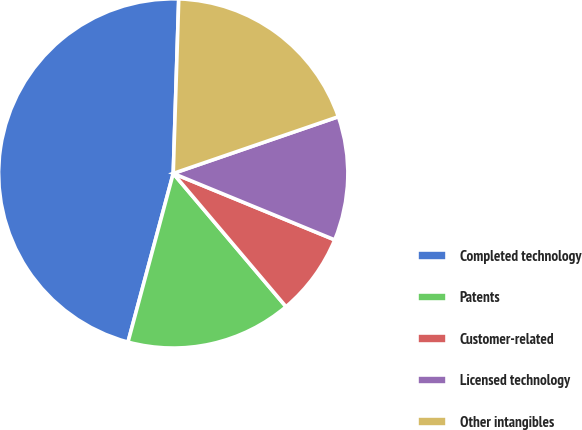<chart> <loc_0><loc_0><loc_500><loc_500><pie_chart><fcel>Completed technology<fcel>Patents<fcel>Customer-related<fcel>Licensed technology<fcel>Other intangibles<nl><fcel>46.33%<fcel>15.35%<fcel>7.61%<fcel>11.48%<fcel>19.23%<nl></chart> 